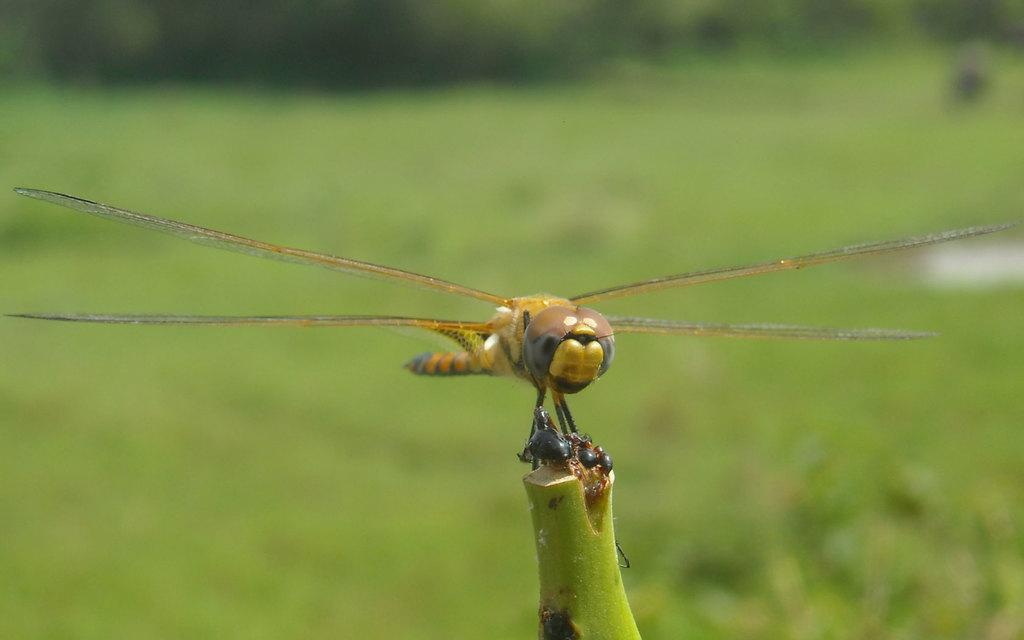What is present in the image? There is an insect in the image. Where is the insect located? The insect is on a plant. What colors can be seen on the insect? The insect has brown and black colors. How would you describe the background of the image? The background of the image is blurred. What type of territory is the insect claiming in the image? There is no indication in the image that the insect is claiming any territory. 